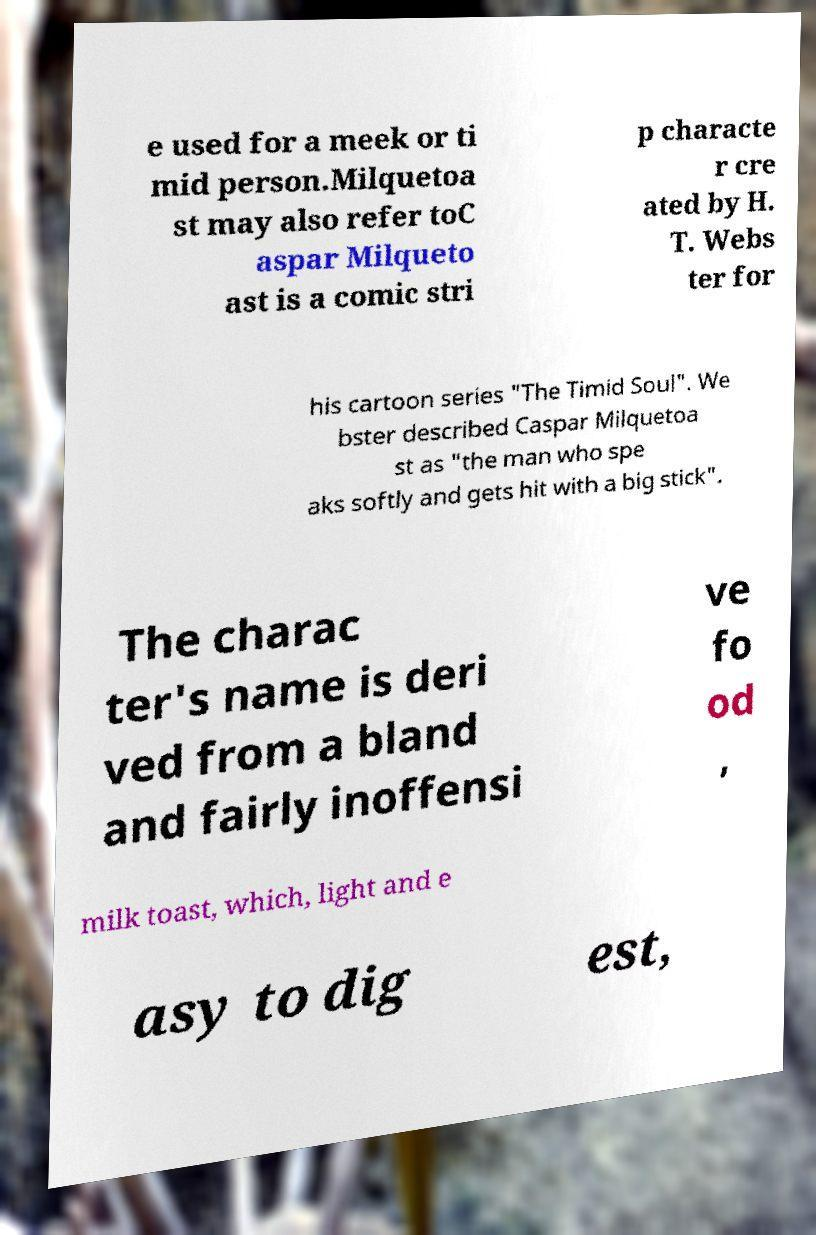I need the written content from this picture converted into text. Can you do that? e used for a meek or ti mid person.Milquetoa st may also refer toC aspar Milqueto ast is a comic stri p characte r cre ated by H. T. Webs ter for his cartoon series "The Timid Soul". We bster described Caspar Milquetoa st as "the man who spe aks softly and gets hit with a big stick". The charac ter's name is deri ved from a bland and fairly inoffensi ve fo od , milk toast, which, light and e asy to dig est, 